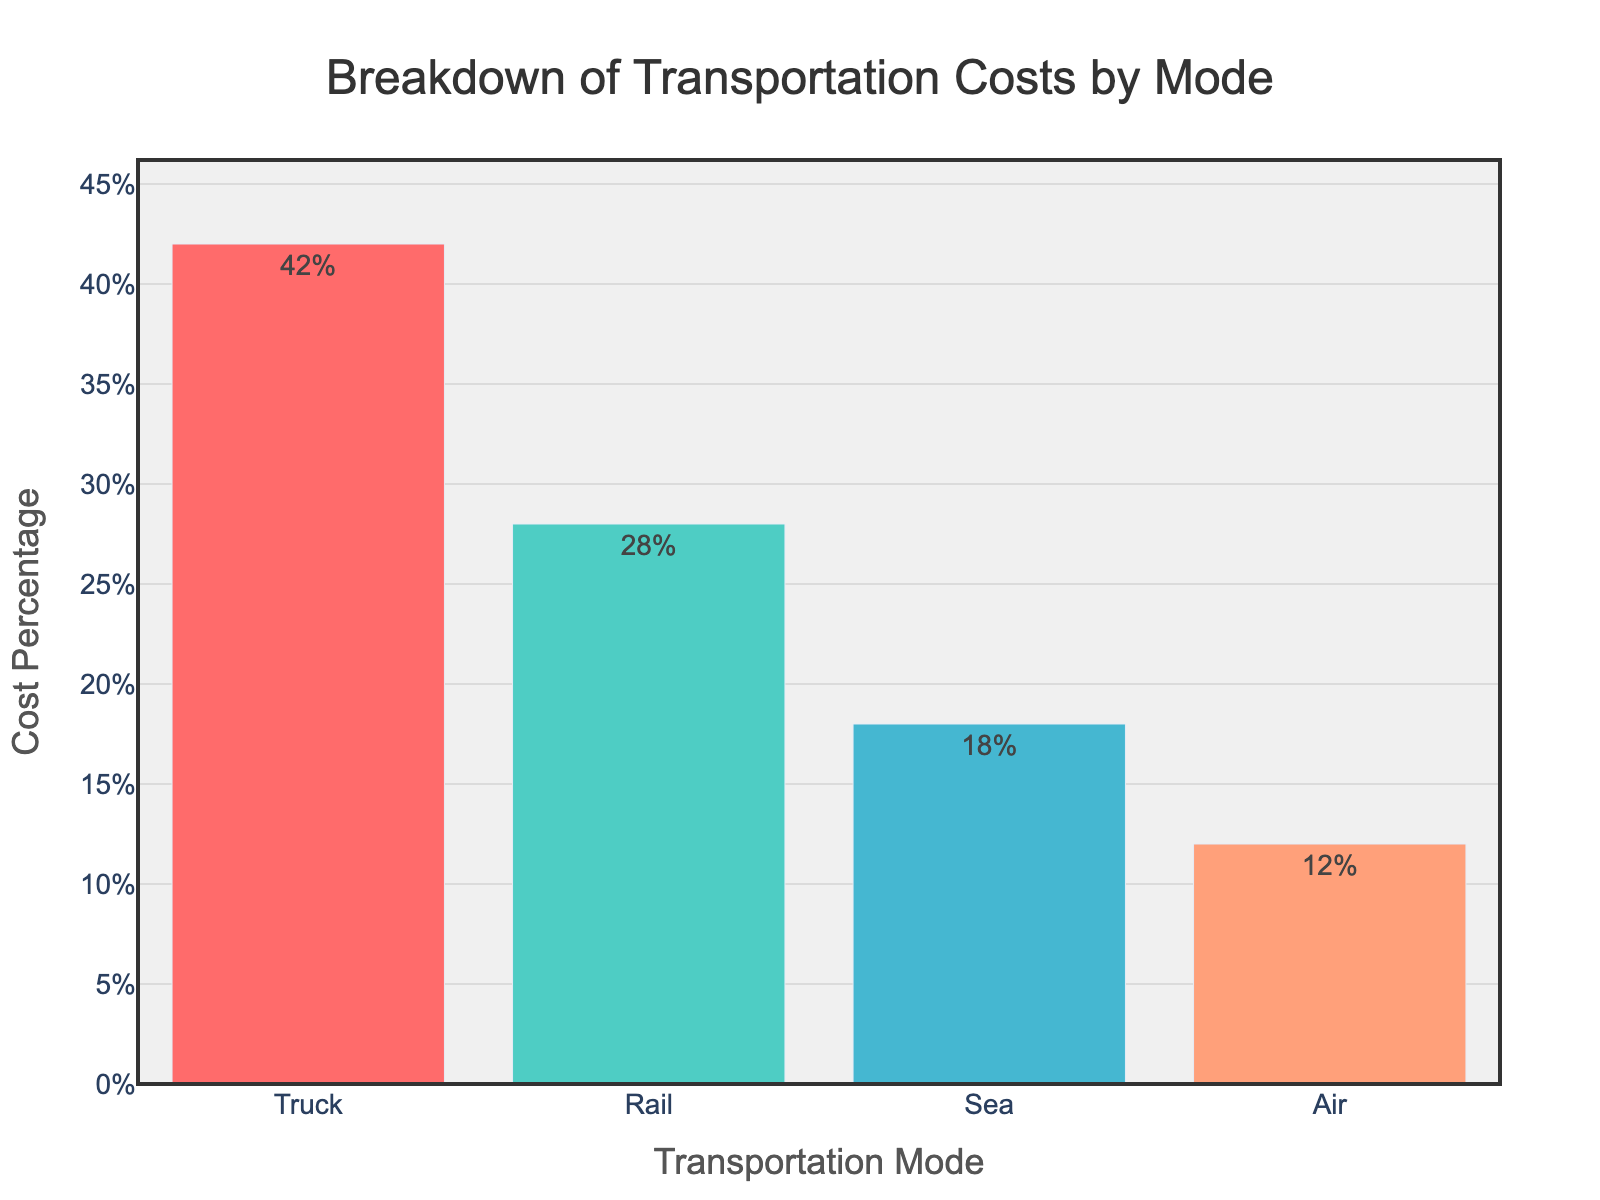What is the transportation mode with the highest cost percentage? The bar chart shows different modes of transportation and their respective cost percentages. By observing the height of each bar, the 'Truck' mode has the highest cost percentage at 42%.
Answer: Truck Which transportation mode has the lowest cost percentage? By checking the bar height corresponding to each mode, the 'Air' mode has the shortest bar, indicating the lowest cost percentage at 12%.
Answer: Air What is the combined cost percentage of Rail and Sea transportation modes? Add the cost percentages of 'Rail' (28%) and 'Sea' (18%). 28 + 18 = 46%.
Answer: 46% How much higher is the cost percentage of Truck compared to Air? Subtract the cost percentage of 'Air' (12%) from 'Truck' (42%). 42 - 12 = 30%.
Answer: 30% If the cost percentage of Air increased by 8 percentage points, what would be its new cost percentage? Add 8 to the current cost percentage of 'Air' mode (12%). 12 + 8 = 20%.
Answer: 20% Which transportation mode has a cost percentage less than Rail but more than Air? Locate percentages between 'Rail' (28%) and 'Air' (12%). The 'Sea' mode, with 18%, fits this condition.
Answer: Sea Is the combined cost percentage of Sea and Air less than that of Truck? Add the cost percentages of 'Sea' (18%) and 'Air' (12%), which equals 30%. Since 30% is less than 'Truck's' 42%, the combined cost percentage is indeed less.
Answer: Yes Rank the transportation modes from highest to lowest cost percentage. By comparing bar heights, the order is 'Truck' (42%), 'Rail' (28%), 'Sea' (18%), and 'Air' (12%).
Answer: Truck, Rail, Sea, Air What is the percentage difference between the second and third most costly transportation modes? Subtract the cost percentage of 'Sea' (18%) from 'Rail' (28%), yielding a difference of 10 percentage points.
Answer: 10% What is the average cost percentage across all transportation modes? Sum the percentages (42 + 28 + 18 + 12 = 100) and divide by the number of modes (4). 100 / 4 = 25%.
Answer: 25% 